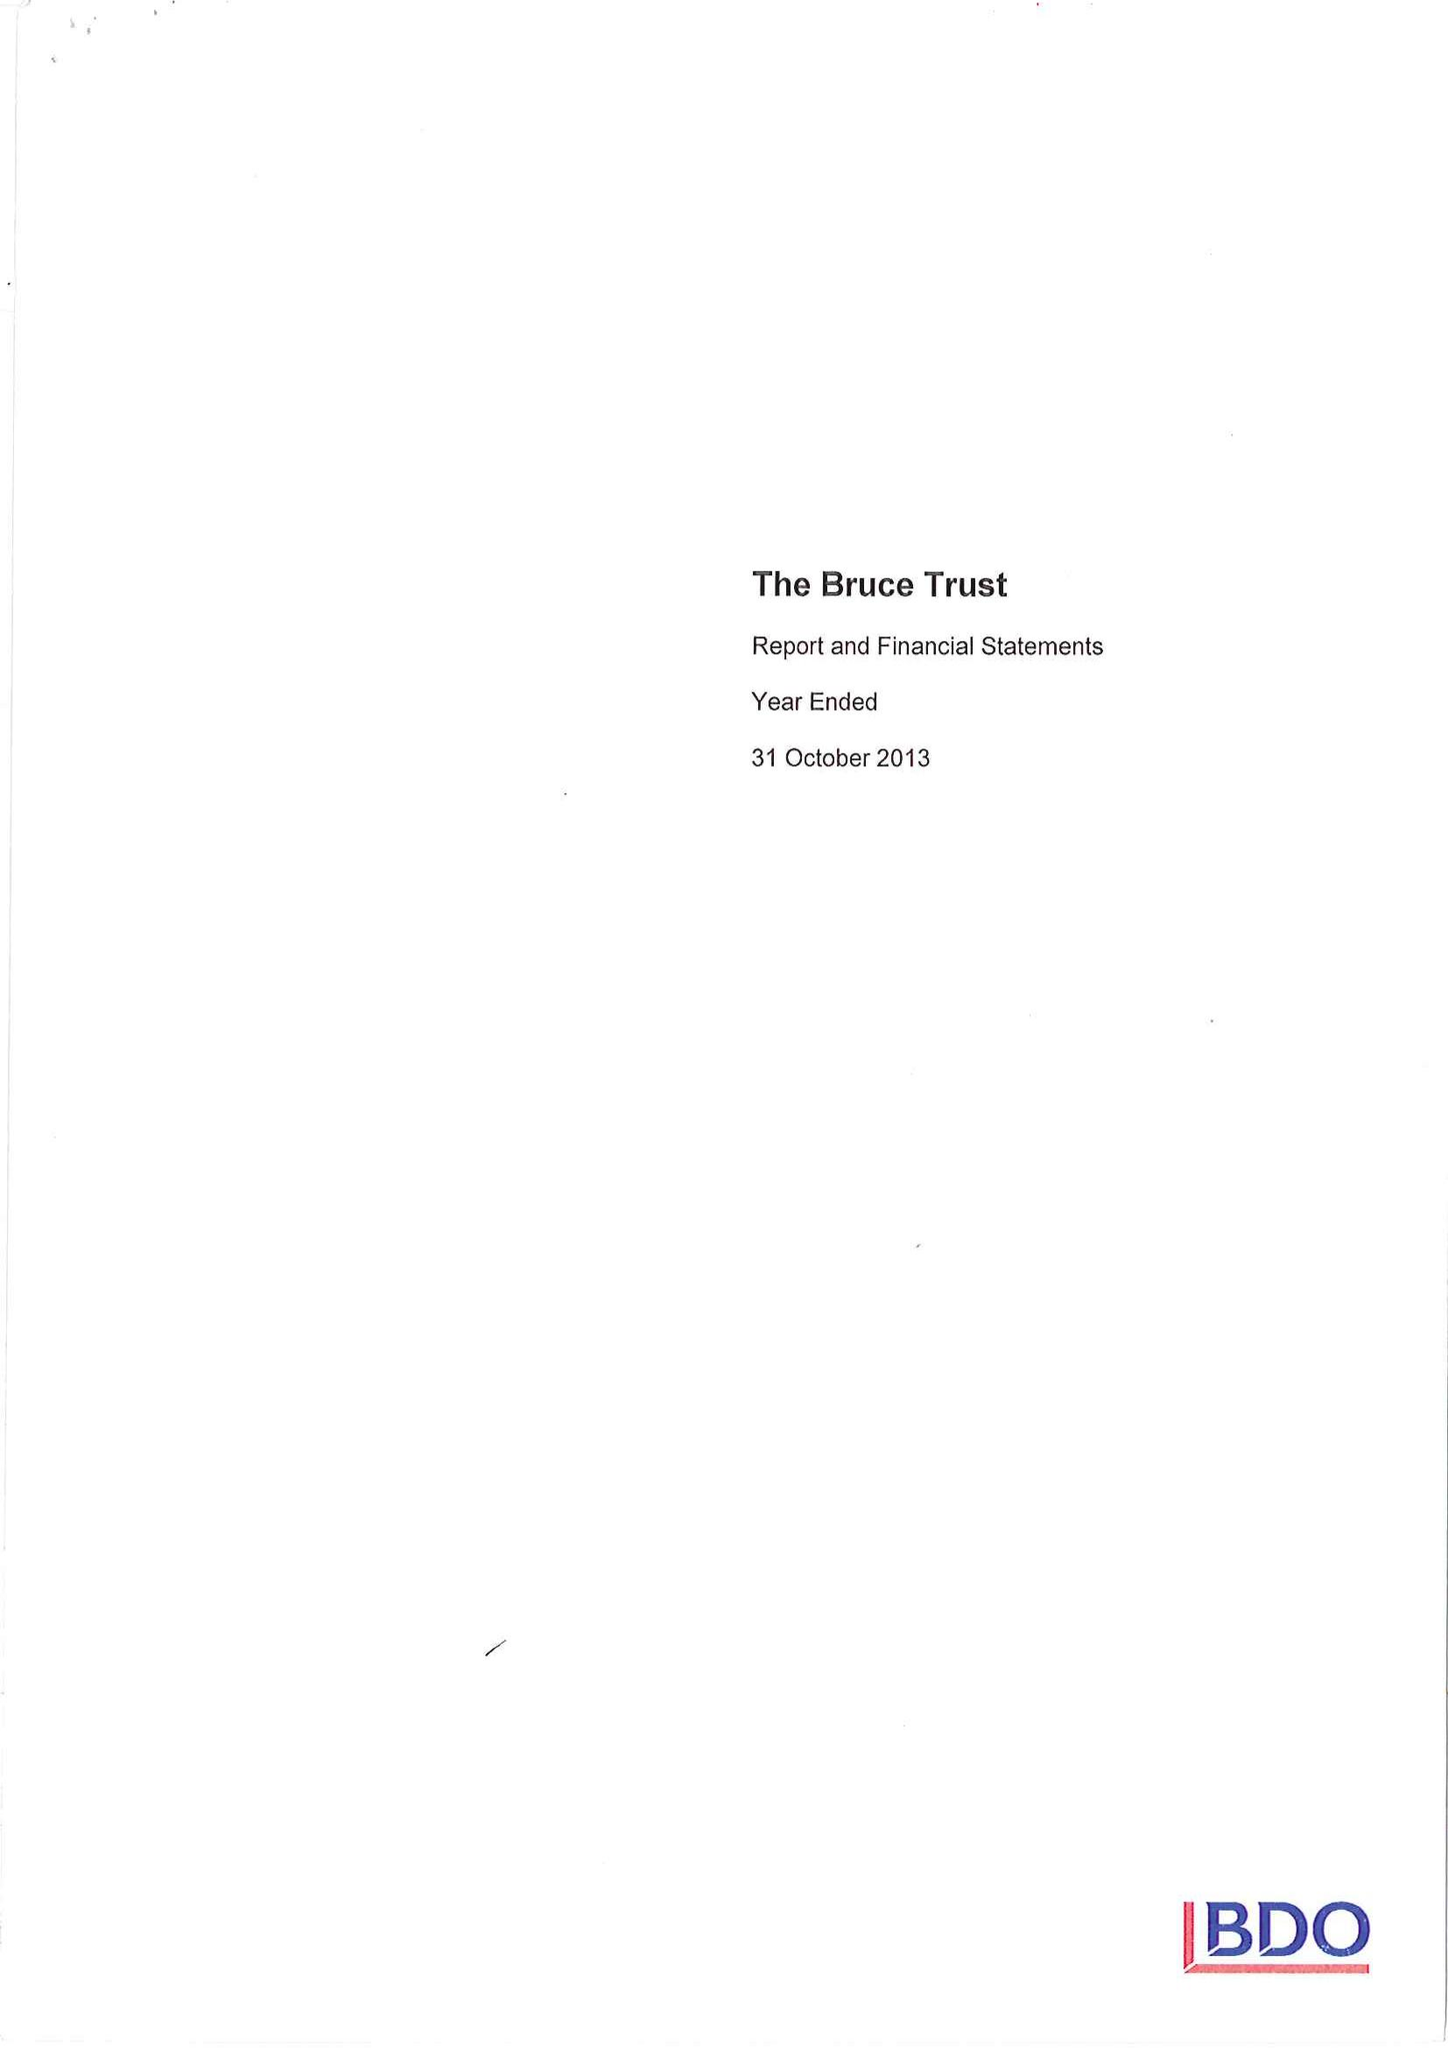What is the value for the charity_name?
Answer the question using a single word or phrase. The Bruce Trust 